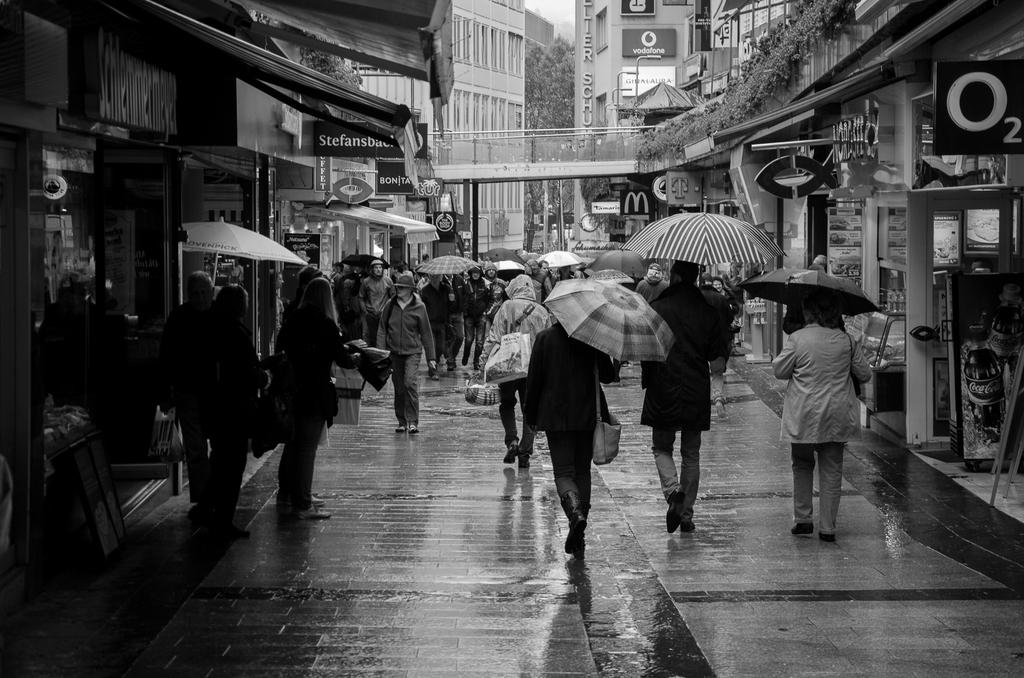What are the people in the image doing? The people in the image are carrying objects. What can be seen in the background of the image? There is a road, stores with posters, poles, a bridge, buildings, trees, and plants visible in the image. What is the condition of the sky in the image? The sky is visible in the image. What type of flowers can be seen growing on the heart in the image? There is no heart or flowers present in the image. How does the look on the person's face change throughout the image? There is no indication of a person's face or any changes in expression in the image. 